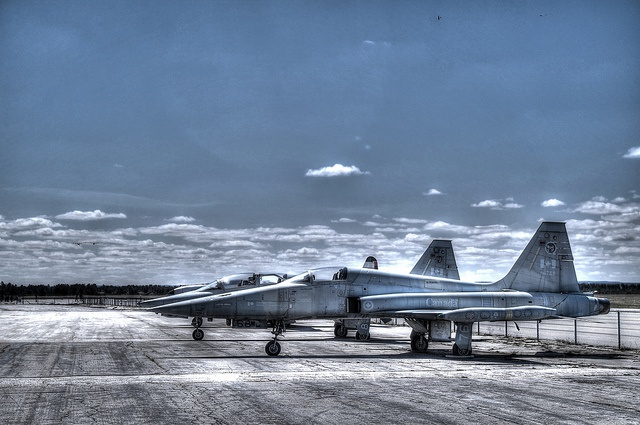Describe the objects in this image and their specific colors. I can see airplane in blue, gray, black, and darkblue tones and airplane in blue, gray, white, and black tones in this image. 